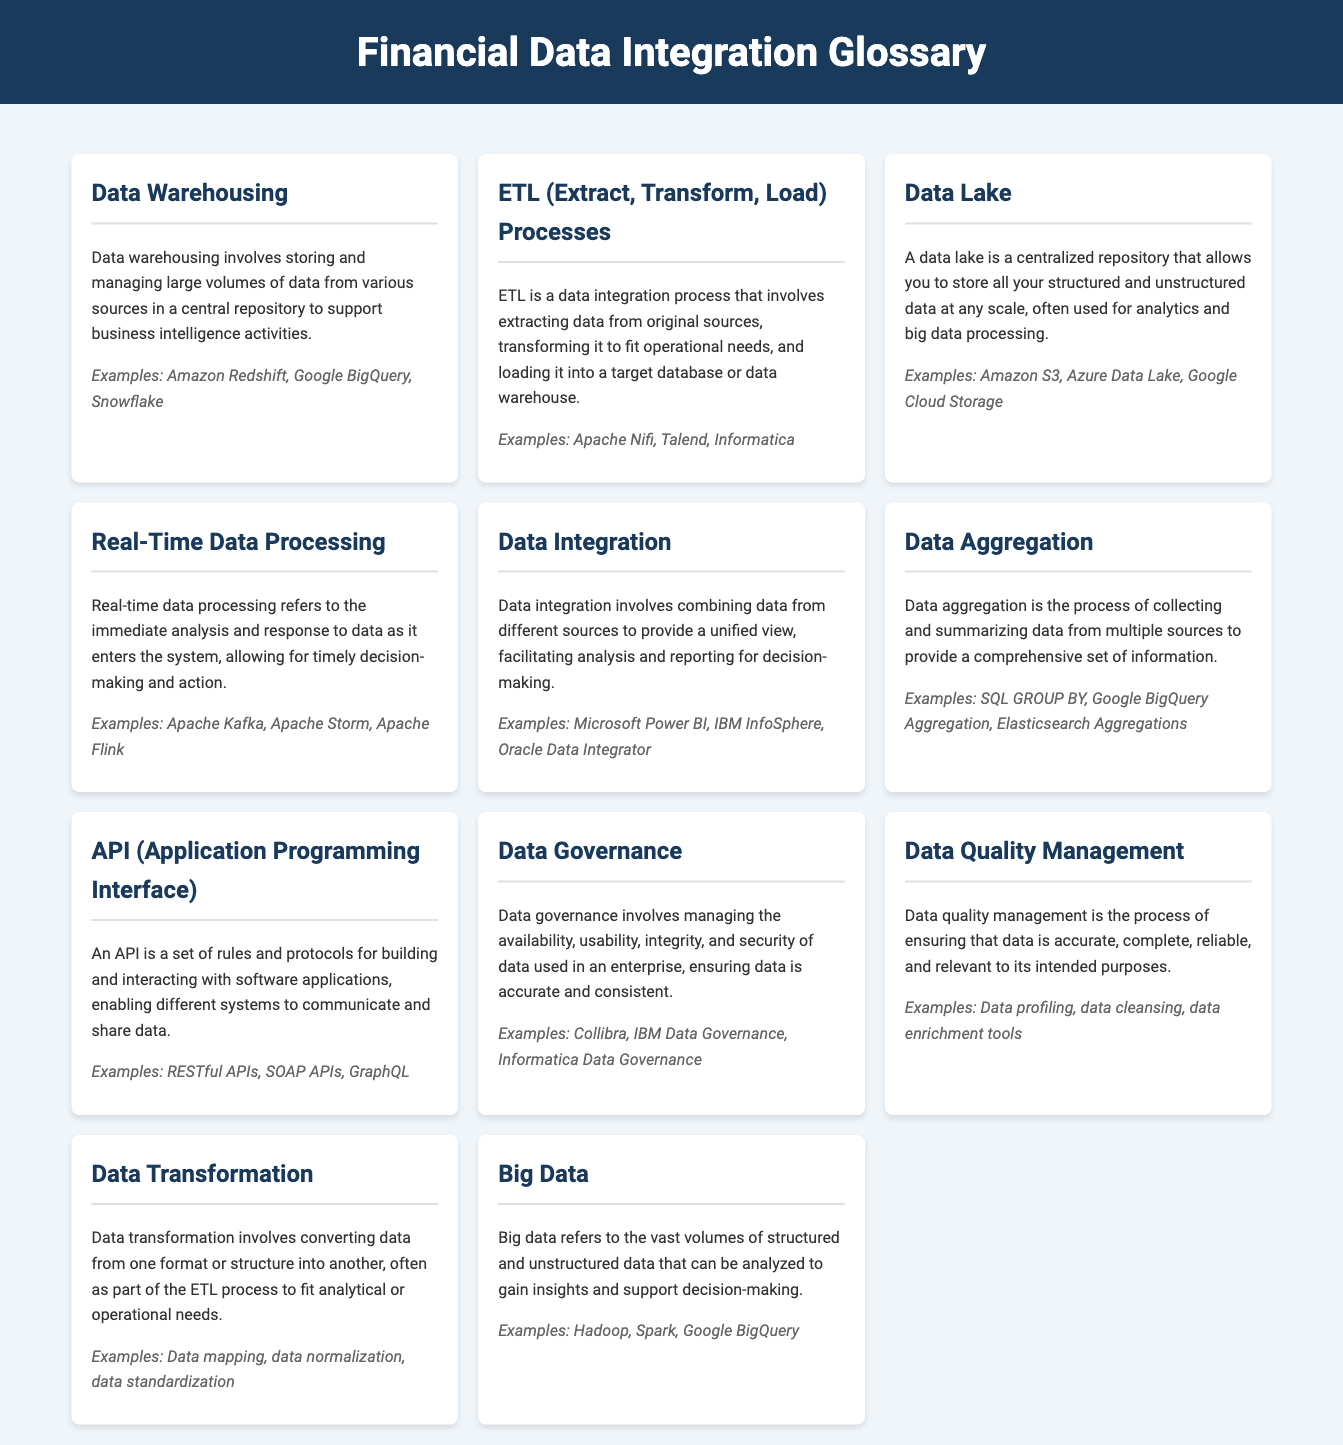What is data warehousing? Data warehousing involves storing and managing large volumes of data from various sources in a central repository to support business intelligence activities.
Answer: Storing and managing large volumes of data What are examples of ETL processes? The document lists Apache Nifi, Talend, and Informatica as examples of ETL processes.
Answer: Apache Nifi, Talend, Informatica What does a data lake allow you to store? A data lake allows you to store all your structured and unstructured data at any scale.
Answer: Structured and unstructured data What is real-time data processing? Real-time data processing refers to the immediate analysis and response to data as it enters the system.
Answer: Immediate analysis and response What do data integration solutions facilitate? Data integration solutions facilitate analysis and reporting for decision-making.
Answer: Analysis and reporting What type of data does big data refer to? Big data refers to vast volumes of structured and unstructured data.
Answer: Vast volumes of data What is the purpose of data governance? The purpose of data governance is to ensure the availability, usability, integrity, and security of data.
Answer: Ensuring data integrity and security Which example corresponds to data aggregation? SQL GROUP BY is provided as an example of data aggregation in the document.
Answer: SQL GROUP BY What process involves converting data from one format to another? Data transformation involves converting data from one format or structure into another.
Answer: Data transformation 